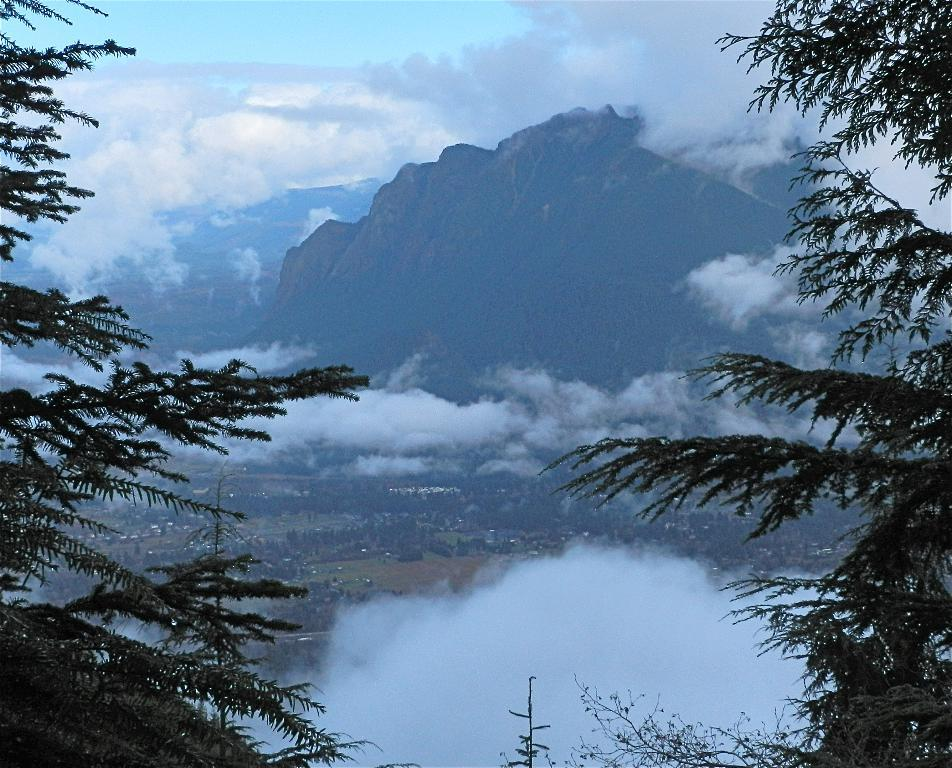What type of vegetation can be seen on the sides of the image? There are trees on the sides of the image. What can be seen in the background of the image? There are clouds, hills, and the sky visible in the background of the image. What type of books can be seen in the image? There are no books present in the image. What sound can be heard from the thunder in the image? There is no thunder present in the image, so no sound can be heard from it. 